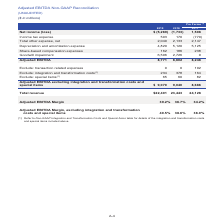According to Centurylink's financial document, Which table should be referred to for details of the integration and transformation costs and special items? Non-GAAP Integration and Transformation Costs and Special Items table. The document states: "(1) Refer to Non-GAAP Integration and Transformation Costs and Special Items table for details of the integration and transformation costs and special..." Also, What is the total revenue for 2019? According to the financial document, $22,401 (in millions). The relevant text states: "Total revenue $22,401 23,443 24,128..." Also, Which items are excluded from the Adjusted EBITDA? The document contains multiple relevant values: transaction related expenses, integration and transformation costs, special items. From the document: "Adjusted EBITDA excluding integration and transformation costs and special items $ 9,070 9,040 8,686 Adjusted EBITDA excluding integration and transfo..." Also, How many items are excluded from the Adjusted EBITDA? Counting the relevant items in the document: transaction related expenses, integration and transformation costs, special items, I find 3 instances. The key data points involved are: integration and transformation costs, special items, transaction related expenses. Also, can you calculate: What is the total change in the Adjusted EBITDA margin between 2019 and 2017? Based on the calculation: 39.2%-34.2%, the result is 5 (percentage). This is based on the information: "Adjusted EBITDA Margin 39.2% 36.7% 34.2% Adjusted EBITDA Margin 39.2% 36.7% 34.2%..." The key data points involved are: 34.2, 39.2. Also, can you calculate: What is the average total revenue across the three years? To answer this question, I need to perform calculations using the financial data. The calculation is: ($22,401+$23,443+$24,128)/3, which equals 23324 (in millions). This is based on the information: "Total revenue $22,401 23,443 24,128 Total revenue $22,401 23,443 24,128 Total revenue $22,401 23,443 24,128..." The key data points involved are: 22,401, 23,443, 24,128. 